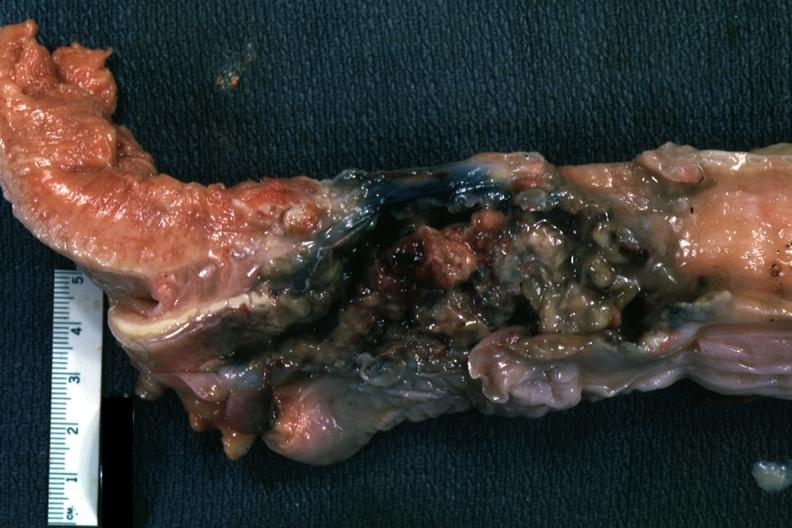s larynx mass of necrotic tissue?
Answer the question using a single word or phrase. Yes 